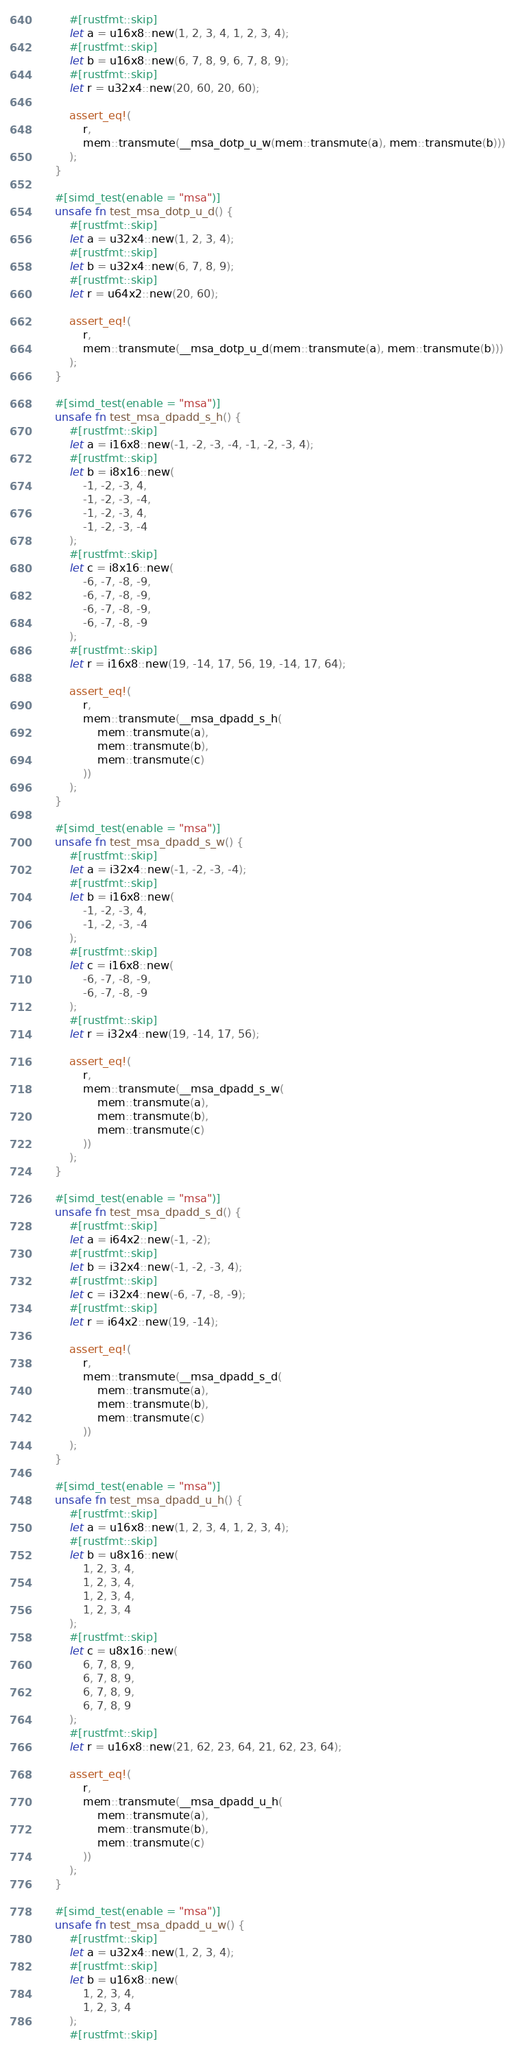Convert code to text. <code><loc_0><loc_0><loc_500><loc_500><_Rust_>        #[rustfmt::skip]
        let a = u16x8::new(1, 2, 3, 4, 1, 2, 3, 4);
        #[rustfmt::skip]
        let b = u16x8::new(6, 7, 8, 9, 6, 7, 8, 9);
        #[rustfmt::skip]
        let r = u32x4::new(20, 60, 20, 60);

        assert_eq!(
            r,
            mem::transmute(__msa_dotp_u_w(mem::transmute(a), mem::transmute(b)))
        );
    }

    #[simd_test(enable = "msa")]
    unsafe fn test_msa_dotp_u_d() {
        #[rustfmt::skip]
        let a = u32x4::new(1, 2, 3, 4);
        #[rustfmt::skip]
        let b = u32x4::new(6, 7, 8, 9);
        #[rustfmt::skip]
        let r = u64x2::new(20, 60);

        assert_eq!(
            r,
            mem::transmute(__msa_dotp_u_d(mem::transmute(a), mem::transmute(b)))
        );
    }

    #[simd_test(enable = "msa")]
    unsafe fn test_msa_dpadd_s_h() {
        #[rustfmt::skip]
        let a = i16x8::new(-1, -2, -3, -4, -1, -2, -3, 4);
        #[rustfmt::skip]
        let b = i8x16::new(
            -1, -2, -3, 4,
            -1, -2, -3, -4,
            -1, -2, -3, 4,
            -1, -2, -3, -4
        );
        #[rustfmt::skip]
        let c = i8x16::new(
            -6, -7, -8, -9,
            -6, -7, -8, -9,
            -6, -7, -8, -9,
            -6, -7, -8, -9
        );
        #[rustfmt::skip]
        let r = i16x8::new(19, -14, 17, 56, 19, -14, 17, 64);

        assert_eq!(
            r,
            mem::transmute(__msa_dpadd_s_h(
                mem::transmute(a),
                mem::transmute(b),
                mem::transmute(c)
            ))
        );
    }

    #[simd_test(enable = "msa")]
    unsafe fn test_msa_dpadd_s_w() {
        #[rustfmt::skip]
        let a = i32x4::new(-1, -2, -3, -4);
        #[rustfmt::skip]
        let b = i16x8::new(
            -1, -2, -3, 4,
            -1, -2, -3, -4
        );
        #[rustfmt::skip]
        let c = i16x8::new(
            -6, -7, -8, -9,
            -6, -7, -8, -9
        );
        #[rustfmt::skip]
        let r = i32x4::new(19, -14, 17, 56);

        assert_eq!(
            r,
            mem::transmute(__msa_dpadd_s_w(
                mem::transmute(a),
                mem::transmute(b),
                mem::transmute(c)
            ))
        );
    }

    #[simd_test(enable = "msa")]
    unsafe fn test_msa_dpadd_s_d() {
        #[rustfmt::skip]
        let a = i64x2::new(-1, -2);
        #[rustfmt::skip]
        let b = i32x4::new(-1, -2, -3, 4);
        #[rustfmt::skip]
        let c = i32x4::new(-6, -7, -8, -9);
        #[rustfmt::skip]
        let r = i64x2::new(19, -14);

        assert_eq!(
            r,
            mem::transmute(__msa_dpadd_s_d(
                mem::transmute(a),
                mem::transmute(b),
                mem::transmute(c)
            ))
        );
    }

    #[simd_test(enable = "msa")]
    unsafe fn test_msa_dpadd_u_h() {
        #[rustfmt::skip]
        let a = u16x8::new(1, 2, 3, 4, 1, 2, 3, 4);
        #[rustfmt::skip]
        let b = u8x16::new(
            1, 2, 3, 4,
            1, 2, 3, 4,
            1, 2, 3, 4,
            1, 2, 3, 4
        );
        #[rustfmt::skip]
        let c = u8x16::new(
            6, 7, 8, 9,
            6, 7, 8, 9,
            6, 7, 8, 9,
            6, 7, 8, 9
        );
        #[rustfmt::skip]
        let r = u16x8::new(21, 62, 23, 64, 21, 62, 23, 64);

        assert_eq!(
            r,
            mem::transmute(__msa_dpadd_u_h(
                mem::transmute(a),
                mem::transmute(b),
                mem::transmute(c)
            ))
        );
    }

    #[simd_test(enable = "msa")]
    unsafe fn test_msa_dpadd_u_w() {
        #[rustfmt::skip]
        let a = u32x4::new(1, 2, 3, 4);
        #[rustfmt::skip]
        let b = u16x8::new(
            1, 2, 3, 4,
            1, 2, 3, 4
        );
        #[rustfmt::skip]</code> 